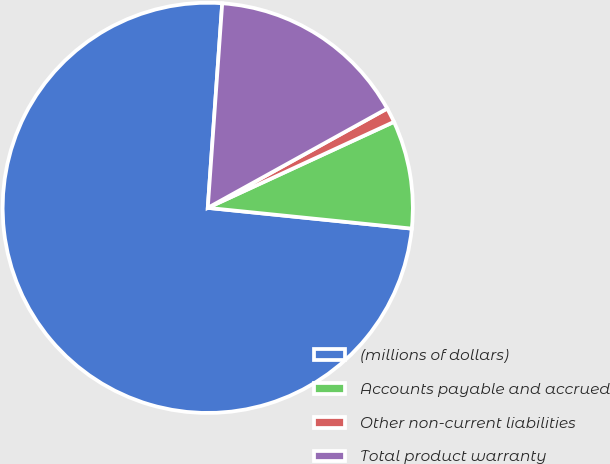<chart> <loc_0><loc_0><loc_500><loc_500><pie_chart><fcel>(millions of dollars)<fcel>Accounts payable and accrued<fcel>Other non-current liabilities<fcel>Total product warranty<nl><fcel>74.51%<fcel>8.5%<fcel>1.16%<fcel>15.83%<nl></chart> 